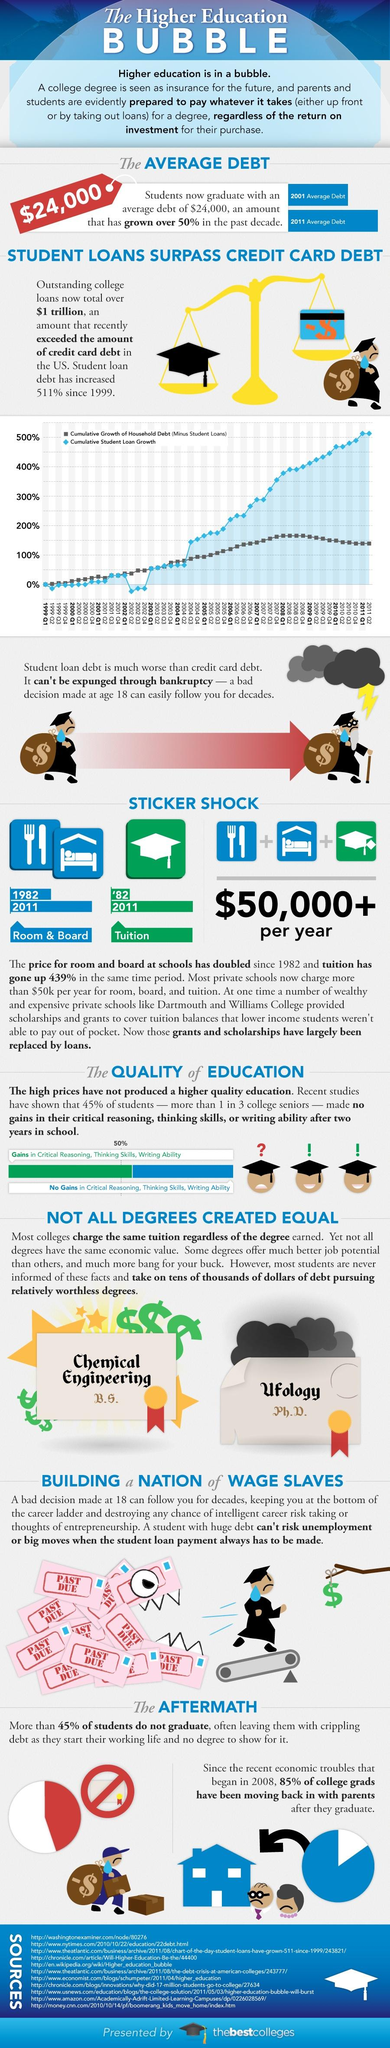Give some essential details in this illustration. The cumulative growth of student loans in the fourth quarter of 2009 was 450%. In the second quarter of 2005, the cumulative growth of household debt, excluding student loans, was 100%. In 2007, cumulative student loan growth surpassed 300%. In 2002, the growth of student loans was less than 0% for three consecutive quarters, indicating a stable financial situation. The growth of cumulative student loans in the third quarter of 2004 was 150%. 